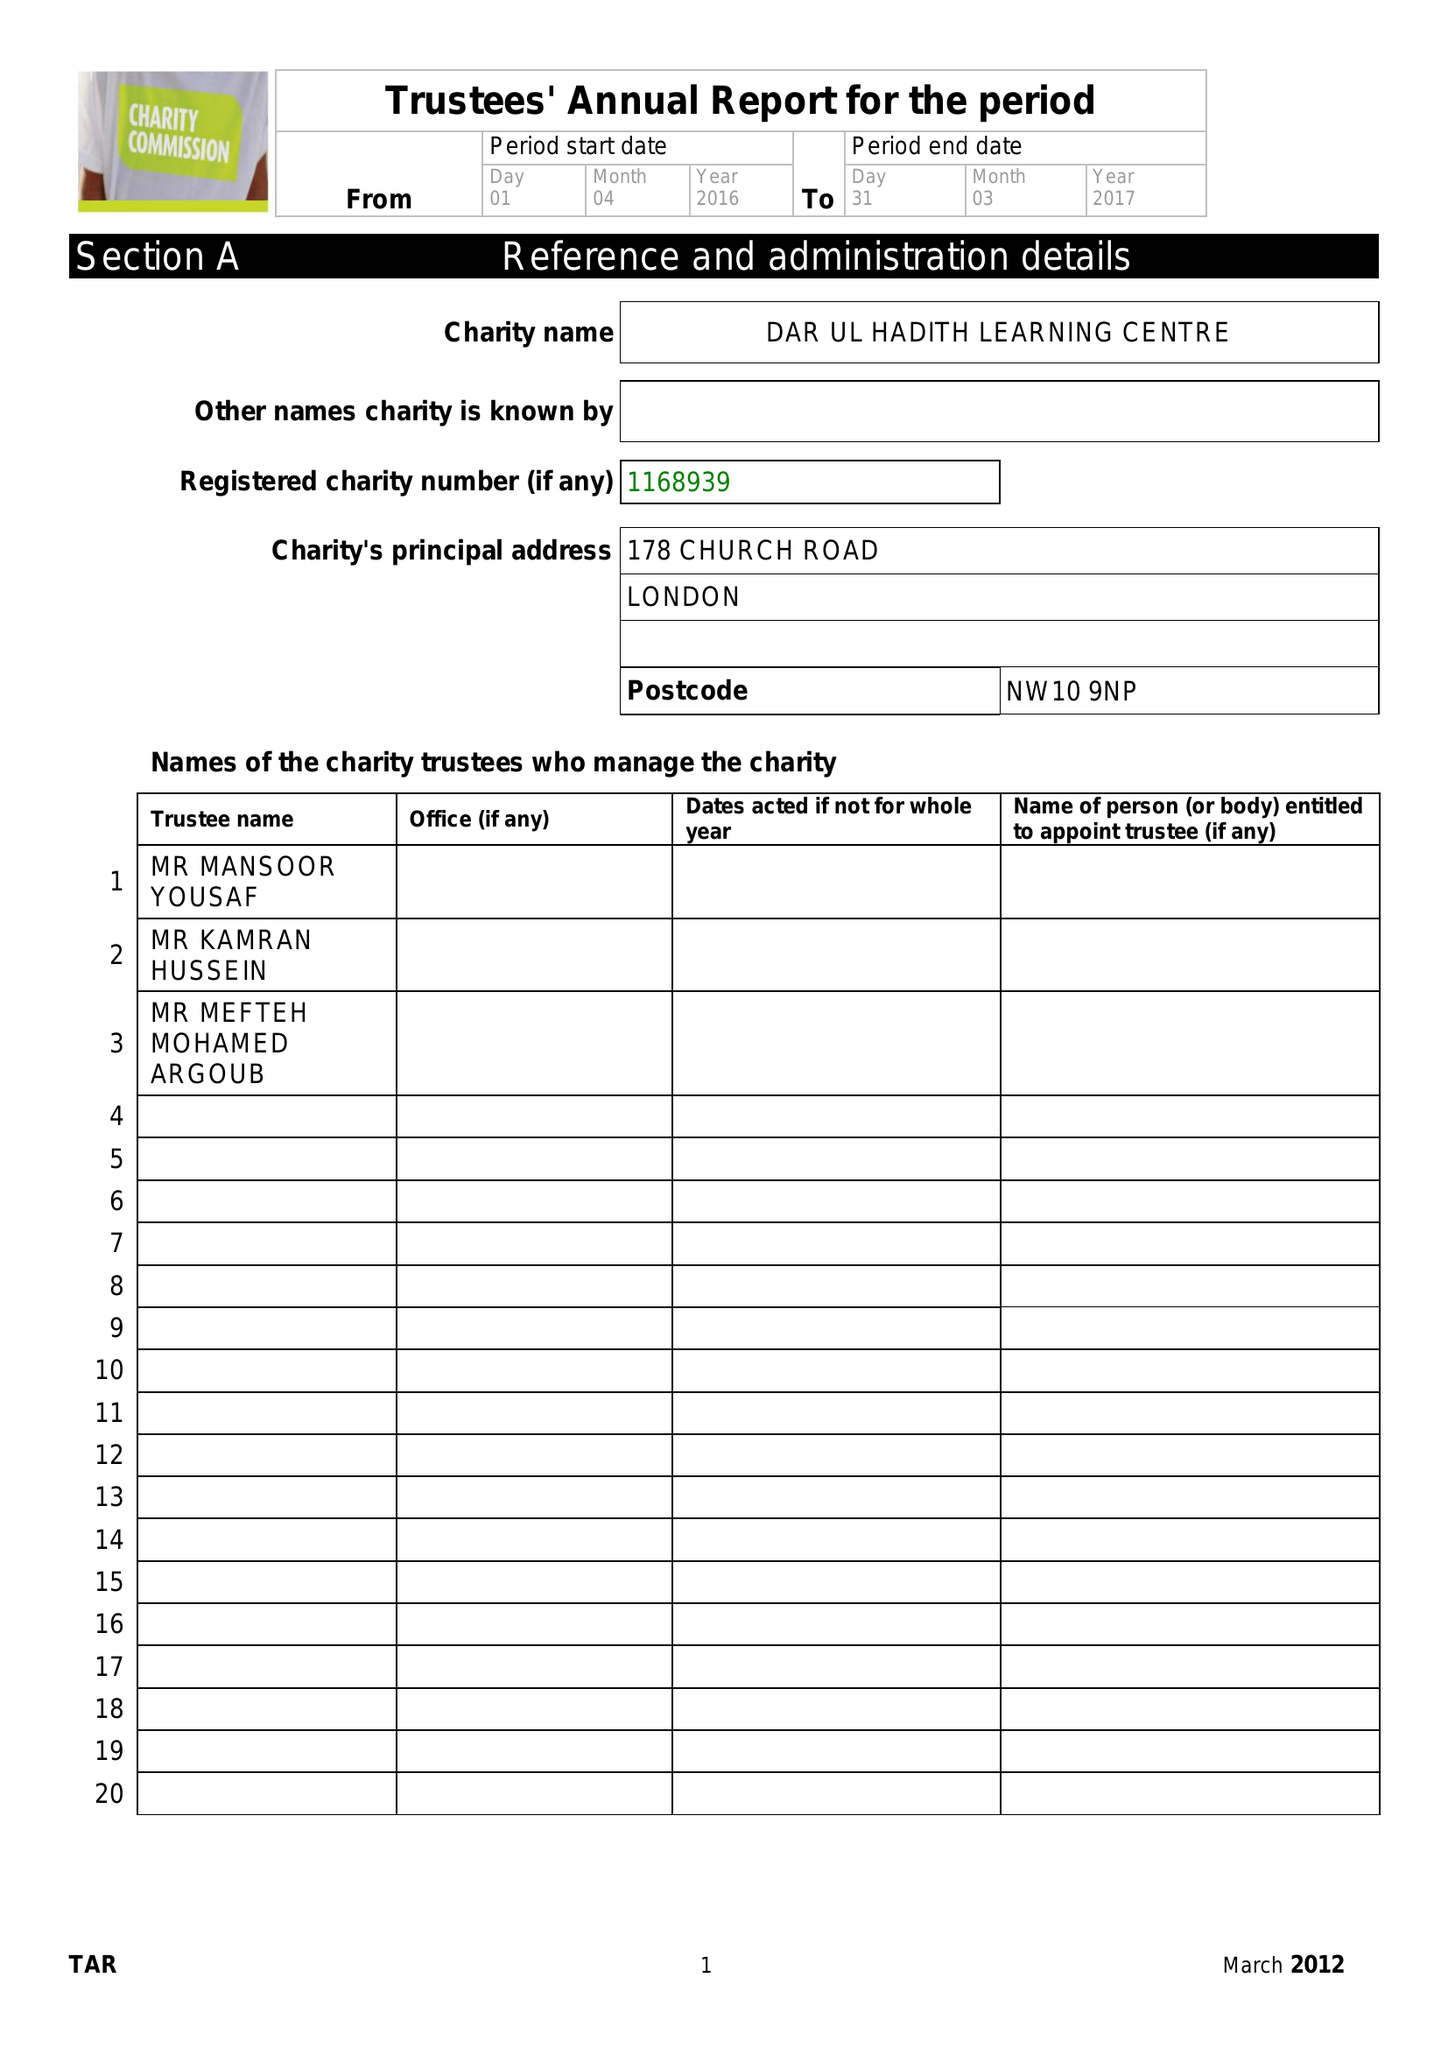What is the value for the report_date?
Answer the question using a single word or phrase. 2017-03-31 